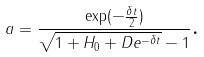Convert formula to latex. <formula><loc_0><loc_0><loc_500><loc_500>a = \frac { \exp ( - \frac { \delta t } { 2 } ) } { \sqrt { 1 + H _ { 0 } + D e ^ { - \delta t } } - 1 } \text {.}</formula> 